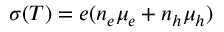<formula> <loc_0><loc_0><loc_500><loc_500>\sigma ( T ) = e ( n _ { e } \mu _ { e } + n _ { h } \mu _ { h } )</formula> 